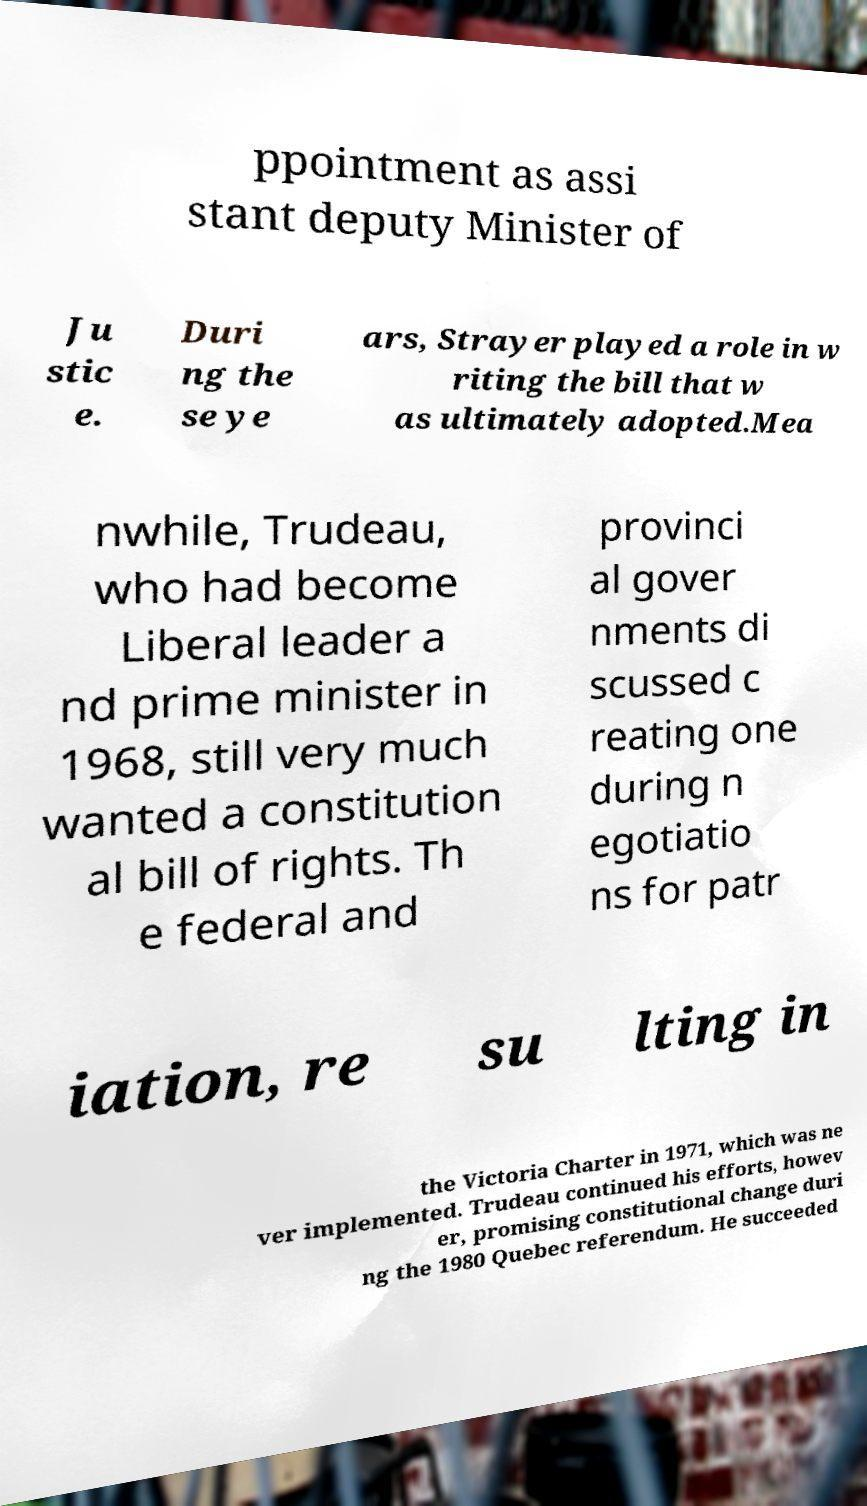There's text embedded in this image that I need extracted. Can you transcribe it verbatim? ppointment as assi stant deputy Minister of Ju stic e. Duri ng the se ye ars, Strayer played a role in w riting the bill that w as ultimately adopted.Mea nwhile, Trudeau, who had become Liberal leader a nd prime minister in 1968, still very much wanted a constitution al bill of rights. Th e federal and provinci al gover nments di scussed c reating one during n egotiatio ns for patr iation, re su lting in the Victoria Charter in 1971, which was ne ver implemented. Trudeau continued his efforts, howev er, promising constitutional change duri ng the 1980 Quebec referendum. He succeeded 